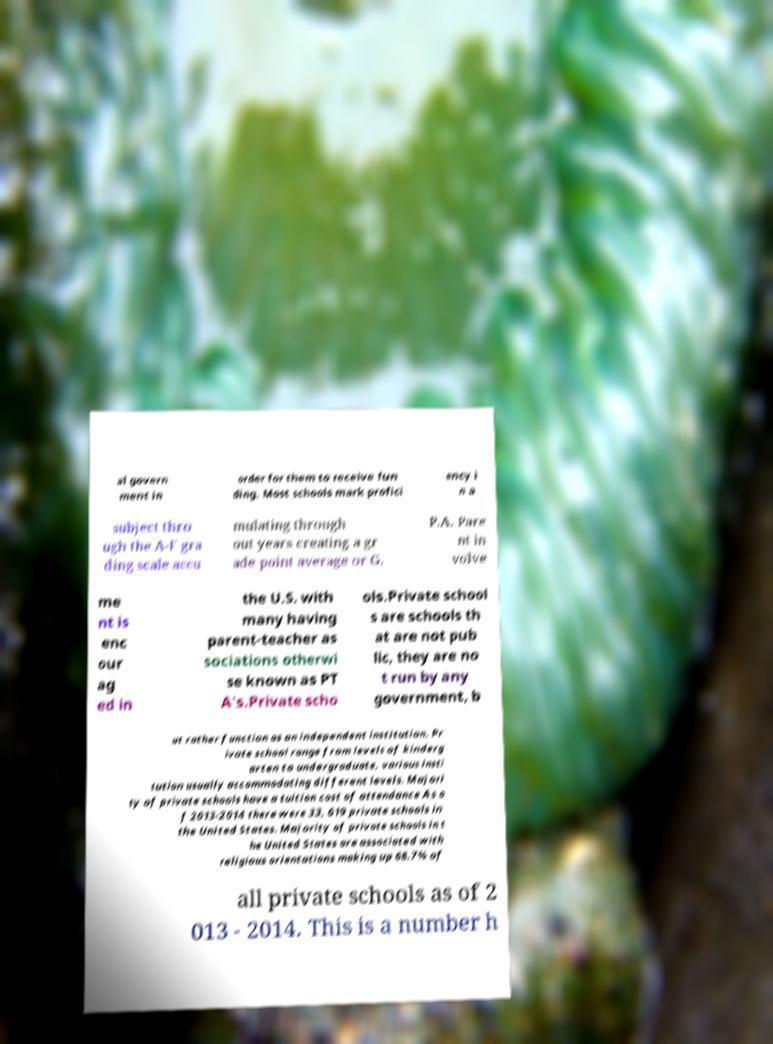For documentation purposes, I need the text within this image transcribed. Could you provide that? al govern ment in order for them to receive fun ding. Most schools mark profici ency i n a subject thro ugh the A-F gra ding scale accu mulating through out years creating a gr ade point average or G. P.A. Pare nt in volve me nt is enc our ag ed in the U.S. with many having parent-teacher as sociations otherwi se known as PT A's.Private scho ols.Private school s are schools th at are not pub lic, they are no t run by any government, b ut rather function as an independent institution. Pr ivate school range from levels of kinderg arten to undergraduate, various insti tution usually accommodating different levels. Majori ty of private schools have a tuition cost of attendance As o f 2013-2014 there were 33, 619 private schools in the United States. Majority of private schools in t he United States are associated with religious orientations making up 68.7% of all private schools as of 2 013 - 2014. This is a number h 